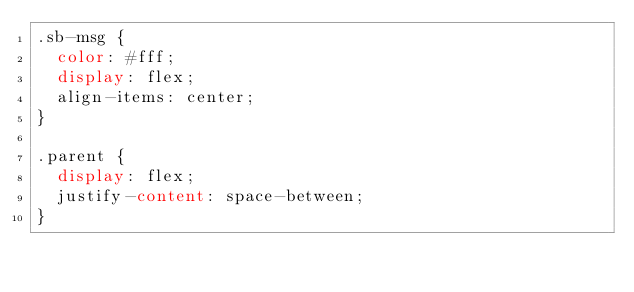Convert code to text. <code><loc_0><loc_0><loc_500><loc_500><_CSS_>.sb-msg {
  color: #fff;
  display: flex;
  align-items: center;
}

.parent {
  display: flex;
  justify-content: space-between;
}


</code> 